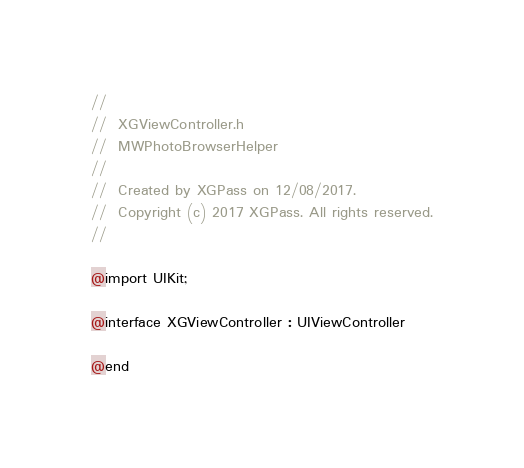Convert code to text. <code><loc_0><loc_0><loc_500><loc_500><_C_>//
//  XGViewController.h
//  MWPhotoBrowserHelper
//
//  Created by XGPass on 12/08/2017.
//  Copyright (c) 2017 XGPass. All rights reserved.
//

@import UIKit;

@interface XGViewController : UIViewController

@end
</code> 